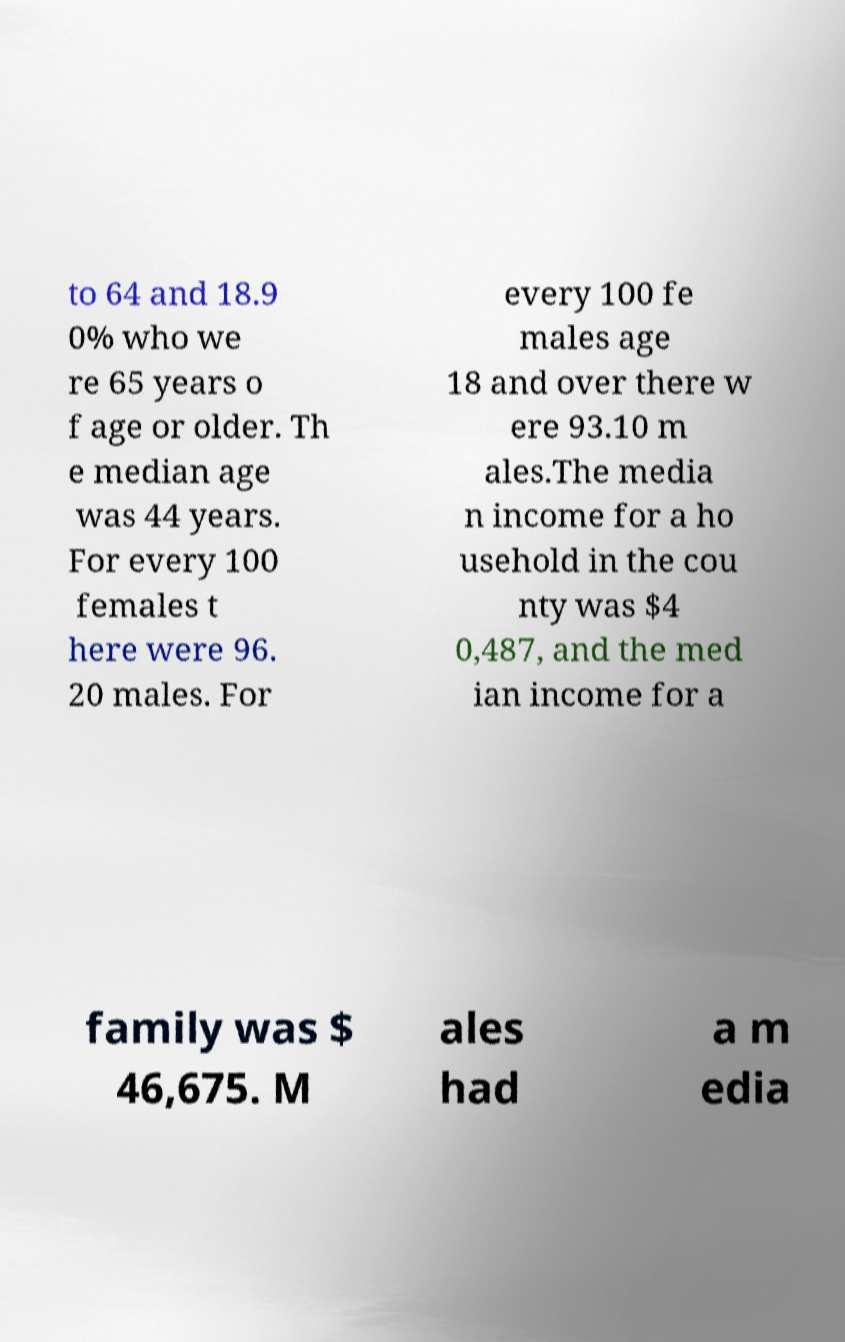I need the written content from this picture converted into text. Can you do that? to 64 and 18.9 0% who we re 65 years o f age or older. Th e median age was 44 years. For every 100 females t here were 96. 20 males. For every 100 fe males age 18 and over there w ere 93.10 m ales.The media n income for a ho usehold in the cou nty was $4 0,487, and the med ian income for a family was $ 46,675. M ales had a m edia 